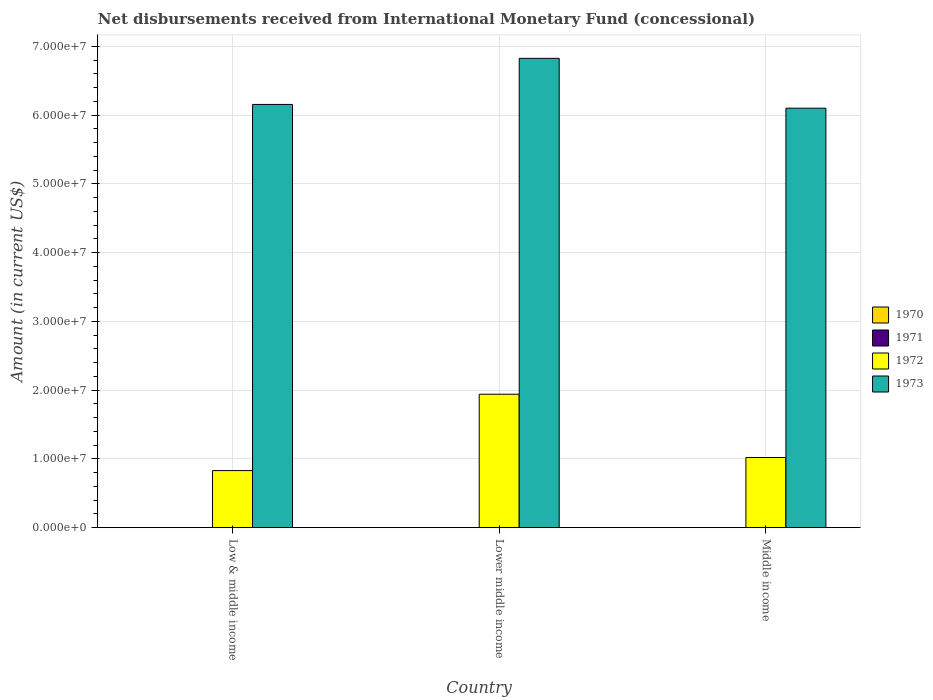How many groups of bars are there?
Your response must be concise. 3. Are the number of bars per tick equal to the number of legend labels?
Ensure brevity in your answer.  No. How many bars are there on the 1st tick from the right?
Provide a succinct answer. 2. In how many cases, is the number of bars for a given country not equal to the number of legend labels?
Provide a short and direct response. 3. What is the amount of disbursements received from International Monetary Fund in 1970 in Lower middle income?
Your answer should be very brief. 0. Across all countries, what is the maximum amount of disbursements received from International Monetary Fund in 1973?
Provide a succinct answer. 6.83e+07. Across all countries, what is the minimum amount of disbursements received from International Monetary Fund in 1970?
Offer a very short reply. 0. In which country was the amount of disbursements received from International Monetary Fund in 1973 maximum?
Offer a very short reply. Lower middle income. What is the total amount of disbursements received from International Monetary Fund in 1972 in the graph?
Your answer should be very brief. 3.79e+07. What is the difference between the amount of disbursements received from International Monetary Fund in 1972 in Low & middle income and that in Lower middle income?
Your answer should be compact. -1.11e+07. What is the difference between the amount of disbursements received from International Monetary Fund in 1972 in Low & middle income and the amount of disbursements received from International Monetary Fund in 1973 in Lower middle income?
Make the answer very short. -6.00e+07. What is the average amount of disbursements received from International Monetary Fund in 1973 per country?
Provide a succinct answer. 6.36e+07. What is the difference between the amount of disbursements received from International Monetary Fund of/in 1972 and amount of disbursements received from International Monetary Fund of/in 1973 in Lower middle income?
Provide a short and direct response. -4.89e+07. In how many countries, is the amount of disbursements received from International Monetary Fund in 1973 greater than 2000000 US$?
Provide a succinct answer. 3. What is the ratio of the amount of disbursements received from International Monetary Fund in 1973 in Lower middle income to that in Middle income?
Make the answer very short. 1.12. Is the amount of disbursements received from International Monetary Fund in 1972 in Low & middle income less than that in Middle income?
Ensure brevity in your answer.  Yes. Is the difference between the amount of disbursements received from International Monetary Fund in 1972 in Lower middle income and Middle income greater than the difference between the amount of disbursements received from International Monetary Fund in 1973 in Lower middle income and Middle income?
Make the answer very short. Yes. What is the difference between the highest and the second highest amount of disbursements received from International Monetary Fund in 1972?
Your response must be concise. 9.21e+06. What is the difference between the highest and the lowest amount of disbursements received from International Monetary Fund in 1973?
Your answer should be compact. 7.25e+06. In how many countries, is the amount of disbursements received from International Monetary Fund in 1973 greater than the average amount of disbursements received from International Monetary Fund in 1973 taken over all countries?
Your answer should be very brief. 1. Is the sum of the amount of disbursements received from International Monetary Fund in 1973 in Lower middle income and Middle income greater than the maximum amount of disbursements received from International Monetary Fund in 1972 across all countries?
Offer a very short reply. Yes. Is it the case that in every country, the sum of the amount of disbursements received from International Monetary Fund in 1970 and amount of disbursements received from International Monetary Fund in 1972 is greater than the sum of amount of disbursements received from International Monetary Fund in 1971 and amount of disbursements received from International Monetary Fund in 1973?
Provide a short and direct response. No. How many bars are there?
Your answer should be compact. 6. Are all the bars in the graph horizontal?
Your answer should be very brief. No. How many countries are there in the graph?
Provide a short and direct response. 3. Are the values on the major ticks of Y-axis written in scientific E-notation?
Make the answer very short. Yes. Where does the legend appear in the graph?
Offer a terse response. Center right. How many legend labels are there?
Give a very brief answer. 4. What is the title of the graph?
Your answer should be compact. Net disbursements received from International Monetary Fund (concessional). Does "1962" appear as one of the legend labels in the graph?
Keep it short and to the point. No. What is the label or title of the Y-axis?
Keep it short and to the point. Amount (in current US$). What is the Amount (in current US$) of 1971 in Low & middle income?
Your answer should be very brief. 0. What is the Amount (in current US$) of 1972 in Low & middle income?
Ensure brevity in your answer.  8.30e+06. What is the Amount (in current US$) in 1973 in Low & middle income?
Keep it short and to the point. 6.16e+07. What is the Amount (in current US$) of 1971 in Lower middle income?
Provide a succinct answer. 0. What is the Amount (in current US$) in 1972 in Lower middle income?
Offer a very short reply. 1.94e+07. What is the Amount (in current US$) in 1973 in Lower middle income?
Provide a succinct answer. 6.83e+07. What is the Amount (in current US$) of 1970 in Middle income?
Make the answer very short. 0. What is the Amount (in current US$) in 1972 in Middle income?
Provide a succinct answer. 1.02e+07. What is the Amount (in current US$) in 1973 in Middle income?
Your response must be concise. 6.10e+07. Across all countries, what is the maximum Amount (in current US$) in 1972?
Provide a short and direct response. 1.94e+07. Across all countries, what is the maximum Amount (in current US$) in 1973?
Keep it short and to the point. 6.83e+07. Across all countries, what is the minimum Amount (in current US$) in 1972?
Provide a succinct answer. 8.30e+06. Across all countries, what is the minimum Amount (in current US$) in 1973?
Your answer should be very brief. 6.10e+07. What is the total Amount (in current US$) of 1970 in the graph?
Offer a very short reply. 0. What is the total Amount (in current US$) in 1972 in the graph?
Your answer should be compact. 3.79e+07. What is the total Amount (in current US$) in 1973 in the graph?
Your answer should be compact. 1.91e+08. What is the difference between the Amount (in current US$) in 1972 in Low & middle income and that in Lower middle income?
Keep it short and to the point. -1.11e+07. What is the difference between the Amount (in current US$) of 1973 in Low & middle income and that in Lower middle income?
Keep it short and to the point. -6.70e+06. What is the difference between the Amount (in current US$) of 1972 in Low & middle income and that in Middle income?
Provide a succinct answer. -1.90e+06. What is the difference between the Amount (in current US$) in 1973 in Low & middle income and that in Middle income?
Your answer should be compact. 5.46e+05. What is the difference between the Amount (in current US$) in 1972 in Lower middle income and that in Middle income?
Make the answer very short. 9.21e+06. What is the difference between the Amount (in current US$) of 1973 in Lower middle income and that in Middle income?
Keep it short and to the point. 7.25e+06. What is the difference between the Amount (in current US$) in 1972 in Low & middle income and the Amount (in current US$) in 1973 in Lower middle income?
Your response must be concise. -6.00e+07. What is the difference between the Amount (in current US$) in 1972 in Low & middle income and the Amount (in current US$) in 1973 in Middle income?
Offer a terse response. -5.27e+07. What is the difference between the Amount (in current US$) of 1972 in Lower middle income and the Amount (in current US$) of 1973 in Middle income?
Your answer should be very brief. -4.16e+07. What is the average Amount (in current US$) of 1972 per country?
Keep it short and to the point. 1.26e+07. What is the average Amount (in current US$) in 1973 per country?
Ensure brevity in your answer.  6.36e+07. What is the difference between the Amount (in current US$) of 1972 and Amount (in current US$) of 1973 in Low & middle income?
Offer a terse response. -5.33e+07. What is the difference between the Amount (in current US$) of 1972 and Amount (in current US$) of 1973 in Lower middle income?
Keep it short and to the point. -4.89e+07. What is the difference between the Amount (in current US$) in 1972 and Amount (in current US$) in 1973 in Middle income?
Offer a very short reply. -5.08e+07. What is the ratio of the Amount (in current US$) of 1972 in Low & middle income to that in Lower middle income?
Ensure brevity in your answer.  0.43. What is the ratio of the Amount (in current US$) of 1973 in Low & middle income to that in Lower middle income?
Provide a succinct answer. 0.9. What is the ratio of the Amount (in current US$) in 1972 in Low & middle income to that in Middle income?
Give a very brief answer. 0.81. What is the ratio of the Amount (in current US$) in 1972 in Lower middle income to that in Middle income?
Offer a terse response. 1.9. What is the ratio of the Amount (in current US$) in 1973 in Lower middle income to that in Middle income?
Ensure brevity in your answer.  1.12. What is the difference between the highest and the second highest Amount (in current US$) in 1972?
Provide a succinct answer. 9.21e+06. What is the difference between the highest and the second highest Amount (in current US$) in 1973?
Offer a very short reply. 6.70e+06. What is the difference between the highest and the lowest Amount (in current US$) in 1972?
Give a very brief answer. 1.11e+07. What is the difference between the highest and the lowest Amount (in current US$) in 1973?
Make the answer very short. 7.25e+06. 